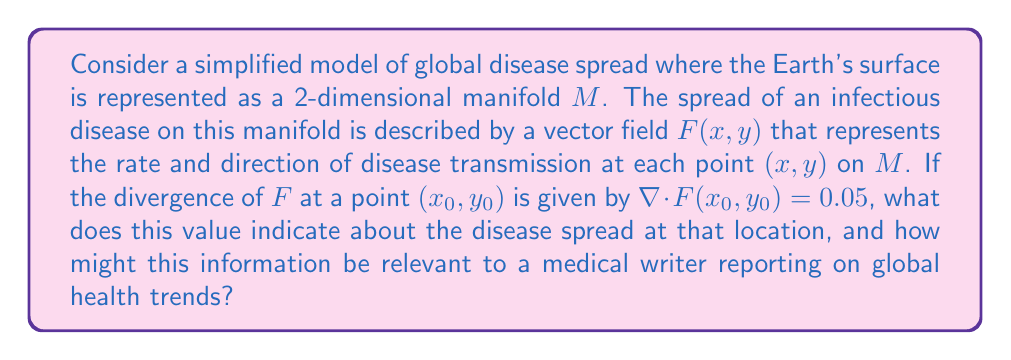Can you solve this math problem? To understand this problem, let's break it down step-by-step:

1) The Earth's surface is modeled as a 2-dimensional manifold $M$. This simplification allows us to apply techniques from differential geometry to study global phenomena.

2) The vector field $F(x,y)$ represents the disease spread. At each point $(x,y)$ on $M$, $F(x,y)$ gives a vector indicating the direction and magnitude of disease transmission.

3) The divergence of a vector field, denoted $\nabla \cdot F$, is a scalar value that measures the "outward flux" of the vector field at a given point. In the context of disease spread:
   - Positive divergence indicates that the disease is spreading outward from the point.
   - Negative divergence indicates that the disease is converging toward the point.
   - Zero divergence suggests neither spreading nor converging at that point.

4) In this case, $\nabla \cdot F(x_0, y_0) = 0.05$. This positive value indicates that at the point $(x_0, y_0)$, the disease is spreading outward.

5) The magnitude of 0.05 suggests a moderate rate of spread. If this value were larger, it would indicate a faster spread; if smaller but still positive, it would indicate a slower spread.

6) For a medical writer, this information is crucial for several reasons:
   - It provides a quantitative measure of disease spread at specific locations.
   - It allows for comparison of spread rates across different regions.
   - It can help identify hotspots of disease transmission.
   - It can inform public health strategies and resource allocation.

7) The use of manifolds and vector calculus in this context demonstrates how advanced mathematical techniques can be applied to global health issues, providing a more sophisticated understanding of disease dynamics.
Answer: The divergence value of 0.05 at the point $(x_0, y_0)$ indicates that the disease is spreading outward from that location at a moderate rate. This information is valuable for a medical writer reporting on global health trends as it provides a quantitative measure of disease transmission, helps identify areas of concern, and can inform public health strategies. 